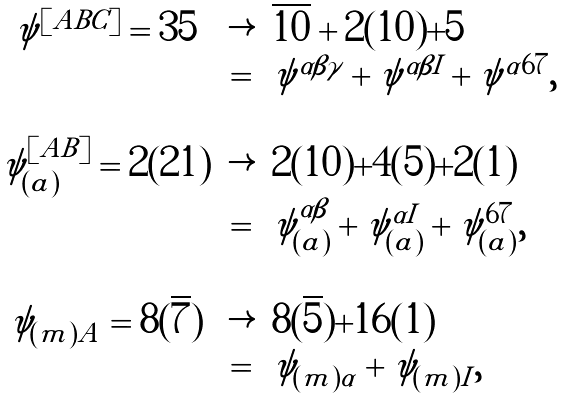<formula> <loc_0><loc_0><loc_500><loc_500>\begin{array} { c c l } \psi ^ { [ A B C ] } = { 3 5 } & \rightarrow & \overline { 1 0 } + 2 ( { 1 0 } ) + { 5 } \\ & = & \psi ^ { \alpha \beta \gamma } + \psi ^ { \alpha \beta I } + \psi ^ { \alpha 6 7 } , \\ & & \\ \psi ^ { [ A B ] } _ { ( a ) } = 2 ( { 2 1 } ) & \rightarrow & 2 ( { 1 0 } ) + 4 ( { 5 } ) + 2 ( { 1 } ) \\ & = & \psi ^ { \alpha \beta } _ { ( a ) } + \psi ^ { \alpha I } _ { ( a ) } + \psi ^ { 6 7 } _ { ( a ) } , \\ & & \\ \psi _ { ( m ) A } = 8 ( \overline { 7 } ) & \rightarrow & 8 ( \overline { 5 } ) + 1 6 ( { 1 } ) \\ & = & \psi _ { ( m ) \alpha } + \psi _ { ( m ) I } , \end{array}</formula> 